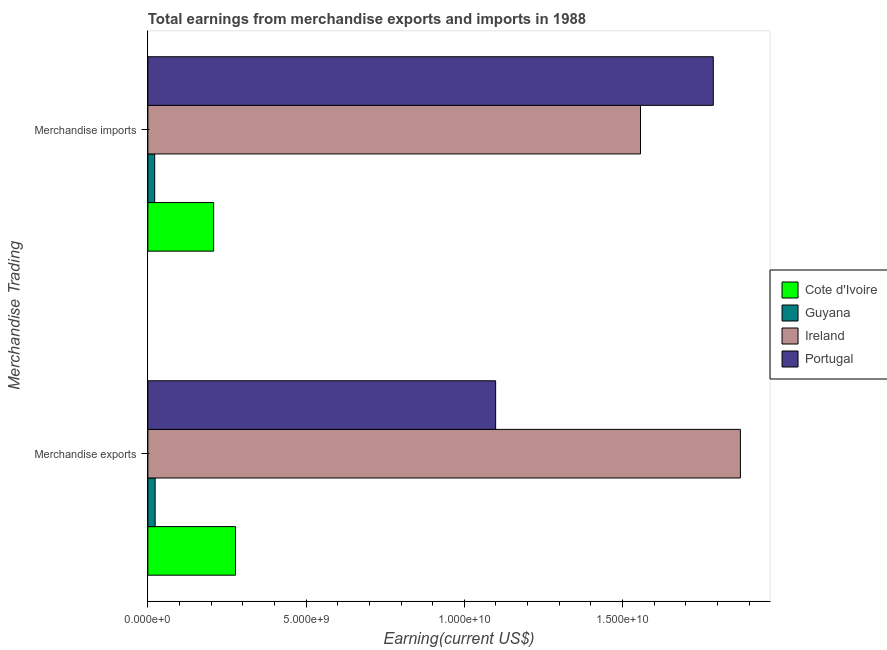How many different coloured bars are there?
Offer a terse response. 4. How many groups of bars are there?
Offer a terse response. 2. Are the number of bars on each tick of the Y-axis equal?
Ensure brevity in your answer.  Yes. How many bars are there on the 2nd tick from the bottom?
Your answer should be very brief. 4. What is the label of the 1st group of bars from the top?
Keep it short and to the point. Merchandise imports. What is the earnings from merchandise exports in Cote d'Ivoire?
Ensure brevity in your answer.  2.77e+09. Across all countries, what is the maximum earnings from merchandise imports?
Provide a short and direct response. 1.79e+1. Across all countries, what is the minimum earnings from merchandise exports?
Ensure brevity in your answer.  2.30e+08. In which country was the earnings from merchandise imports maximum?
Provide a short and direct response. Portugal. In which country was the earnings from merchandise exports minimum?
Your answer should be very brief. Guyana. What is the total earnings from merchandise exports in the graph?
Give a very brief answer. 3.27e+1. What is the difference between the earnings from merchandise imports in Portugal and that in Cote d'Ivoire?
Ensure brevity in your answer.  1.58e+1. What is the difference between the earnings from merchandise exports in Ireland and the earnings from merchandise imports in Guyana?
Provide a short and direct response. 1.85e+1. What is the average earnings from merchandise imports per country?
Provide a succinct answer. 8.93e+09. What is the difference between the earnings from merchandise imports and earnings from merchandise exports in Portugal?
Offer a terse response. 6.88e+09. What is the ratio of the earnings from merchandise imports in Cote d'Ivoire to that in Guyana?
Give a very brief answer. 9.62. What does the 4th bar from the top in Merchandise exports represents?
Give a very brief answer. Cote d'Ivoire. What does the 3rd bar from the bottom in Merchandise exports represents?
Provide a succinct answer. Ireland. What is the difference between two consecutive major ticks on the X-axis?
Offer a very short reply. 5.00e+09. Does the graph contain any zero values?
Your answer should be very brief. No. Does the graph contain grids?
Keep it short and to the point. No. Where does the legend appear in the graph?
Provide a short and direct response. Center right. What is the title of the graph?
Provide a short and direct response. Total earnings from merchandise exports and imports in 1988. Does "Brazil" appear as one of the legend labels in the graph?
Ensure brevity in your answer.  No. What is the label or title of the X-axis?
Provide a short and direct response. Earning(current US$). What is the label or title of the Y-axis?
Give a very brief answer. Merchandise Trading. What is the Earning(current US$) of Cote d'Ivoire in Merchandise exports?
Provide a succinct answer. 2.77e+09. What is the Earning(current US$) of Guyana in Merchandise exports?
Your response must be concise. 2.30e+08. What is the Earning(current US$) in Ireland in Merchandise exports?
Your answer should be very brief. 1.87e+1. What is the Earning(current US$) of Portugal in Merchandise exports?
Keep it short and to the point. 1.10e+1. What is the Earning(current US$) of Cote d'Ivoire in Merchandise imports?
Offer a very short reply. 2.08e+09. What is the Earning(current US$) in Guyana in Merchandise imports?
Your response must be concise. 2.16e+08. What is the Earning(current US$) in Ireland in Merchandise imports?
Offer a terse response. 1.56e+1. What is the Earning(current US$) in Portugal in Merchandise imports?
Provide a short and direct response. 1.79e+1. Across all Merchandise Trading, what is the maximum Earning(current US$) in Cote d'Ivoire?
Make the answer very short. 2.77e+09. Across all Merchandise Trading, what is the maximum Earning(current US$) in Guyana?
Your answer should be compact. 2.30e+08. Across all Merchandise Trading, what is the maximum Earning(current US$) in Ireland?
Provide a short and direct response. 1.87e+1. Across all Merchandise Trading, what is the maximum Earning(current US$) in Portugal?
Ensure brevity in your answer.  1.79e+1. Across all Merchandise Trading, what is the minimum Earning(current US$) of Cote d'Ivoire?
Offer a very short reply. 2.08e+09. Across all Merchandise Trading, what is the minimum Earning(current US$) of Guyana?
Offer a very short reply. 2.16e+08. Across all Merchandise Trading, what is the minimum Earning(current US$) in Ireland?
Give a very brief answer. 1.56e+1. Across all Merchandise Trading, what is the minimum Earning(current US$) in Portugal?
Your answer should be compact. 1.10e+1. What is the total Earning(current US$) in Cote d'Ivoire in the graph?
Give a very brief answer. 4.85e+09. What is the total Earning(current US$) of Guyana in the graph?
Provide a succinct answer. 4.46e+08. What is the total Earning(current US$) in Ireland in the graph?
Provide a short and direct response. 3.43e+1. What is the total Earning(current US$) in Portugal in the graph?
Offer a very short reply. 2.89e+1. What is the difference between the Earning(current US$) in Cote d'Ivoire in Merchandise exports and that in Merchandise imports?
Your response must be concise. 6.90e+08. What is the difference between the Earning(current US$) of Guyana in Merchandise exports and that in Merchandise imports?
Your answer should be very brief. 1.40e+07. What is the difference between the Earning(current US$) in Ireland in Merchandise exports and that in Merchandise imports?
Your answer should be very brief. 3.16e+09. What is the difference between the Earning(current US$) of Portugal in Merchandise exports and that in Merchandise imports?
Your response must be concise. -6.88e+09. What is the difference between the Earning(current US$) in Cote d'Ivoire in Merchandise exports and the Earning(current US$) in Guyana in Merchandise imports?
Ensure brevity in your answer.  2.55e+09. What is the difference between the Earning(current US$) of Cote d'Ivoire in Merchandise exports and the Earning(current US$) of Ireland in Merchandise imports?
Offer a very short reply. -1.28e+1. What is the difference between the Earning(current US$) in Cote d'Ivoire in Merchandise exports and the Earning(current US$) in Portugal in Merchandise imports?
Keep it short and to the point. -1.51e+1. What is the difference between the Earning(current US$) in Guyana in Merchandise exports and the Earning(current US$) in Ireland in Merchandise imports?
Offer a very short reply. -1.53e+1. What is the difference between the Earning(current US$) in Guyana in Merchandise exports and the Earning(current US$) in Portugal in Merchandise imports?
Your response must be concise. -1.76e+1. What is the difference between the Earning(current US$) of Ireland in Merchandise exports and the Earning(current US$) of Portugal in Merchandise imports?
Your response must be concise. 8.57e+08. What is the average Earning(current US$) in Cote d'Ivoire per Merchandise Trading?
Ensure brevity in your answer.  2.42e+09. What is the average Earning(current US$) in Guyana per Merchandise Trading?
Your answer should be compact. 2.23e+08. What is the average Earning(current US$) in Ireland per Merchandise Trading?
Your answer should be very brief. 1.71e+1. What is the average Earning(current US$) in Portugal per Merchandise Trading?
Provide a short and direct response. 1.44e+1. What is the difference between the Earning(current US$) in Cote d'Ivoire and Earning(current US$) in Guyana in Merchandise exports?
Keep it short and to the point. 2.54e+09. What is the difference between the Earning(current US$) in Cote d'Ivoire and Earning(current US$) in Ireland in Merchandise exports?
Ensure brevity in your answer.  -1.60e+1. What is the difference between the Earning(current US$) in Cote d'Ivoire and Earning(current US$) in Portugal in Merchandise exports?
Keep it short and to the point. -8.22e+09. What is the difference between the Earning(current US$) of Guyana and Earning(current US$) of Ireland in Merchandise exports?
Provide a short and direct response. -1.85e+1. What is the difference between the Earning(current US$) in Guyana and Earning(current US$) in Portugal in Merchandise exports?
Your answer should be very brief. -1.08e+1. What is the difference between the Earning(current US$) of Ireland and Earning(current US$) of Portugal in Merchandise exports?
Provide a short and direct response. 7.73e+09. What is the difference between the Earning(current US$) of Cote d'Ivoire and Earning(current US$) of Guyana in Merchandise imports?
Your answer should be very brief. 1.86e+09. What is the difference between the Earning(current US$) in Cote d'Ivoire and Earning(current US$) in Ireland in Merchandise imports?
Your answer should be compact. -1.35e+1. What is the difference between the Earning(current US$) in Cote d'Ivoire and Earning(current US$) in Portugal in Merchandise imports?
Your response must be concise. -1.58e+1. What is the difference between the Earning(current US$) in Guyana and Earning(current US$) in Ireland in Merchandise imports?
Offer a terse response. -1.54e+1. What is the difference between the Earning(current US$) in Guyana and Earning(current US$) in Portugal in Merchandise imports?
Provide a succinct answer. -1.76e+1. What is the difference between the Earning(current US$) of Ireland and Earning(current US$) of Portugal in Merchandise imports?
Make the answer very short. -2.30e+09. What is the ratio of the Earning(current US$) of Cote d'Ivoire in Merchandise exports to that in Merchandise imports?
Provide a short and direct response. 1.33. What is the ratio of the Earning(current US$) in Guyana in Merchandise exports to that in Merchandise imports?
Offer a terse response. 1.06. What is the ratio of the Earning(current US$) of Ireland in Merchandise exports to that in Merchandise imports?
Offer a very short reply. 1.2. What is the ratio of the Earning(current US$) of Portugal in Merchandise exports to that in Merchandise imports?
Your response must be concise. 0.62. What is the difference between the highest and the second highest Earning(current US$) in Cote d'Ivoire?
Provide a succinct answer. 6.90e+08. What is the difference between the highest and the second highest Earning(current US$) of Guyana?
Give a very brief answer. 1.40e+07. What is the difference between the highest and the second highest Earning(current US$) of Ireland?
Offer a very short reply. 3.16e+09. What is the difference between the highest and the second highest Earning(current US$) in Portugal?
Offer a terse response. 6.88e+09. What is the difference between the highest and the lowest Earning(current US$) in Cote d'Ivoire?
Your response must be concise. 6.90e+08. What is the difference between the highest and the lowest Earning(current US$) in Guyana?
Your answer should be compact. 1.40e+07. What is the difference between the highest and the lowest Earning(current US$) of Ireland?
Give a very brief answer. 3.16e+09. What is the difference between the highest and the lowest Earning(current US$) of Portugal?
Your answer should be compact. 6.88e+09. 